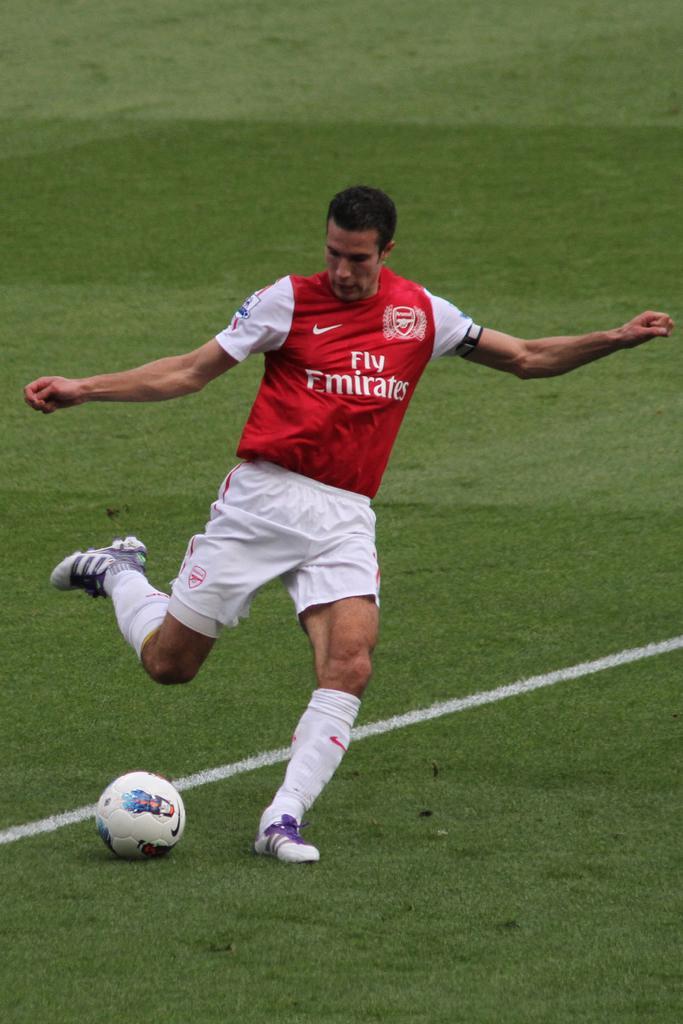Describe this image in one or two sentences. In this image I can see a man is standing. The man is wearing jersey, shorts and footwear. I can also see a ball, the grass and white line on the ground. 